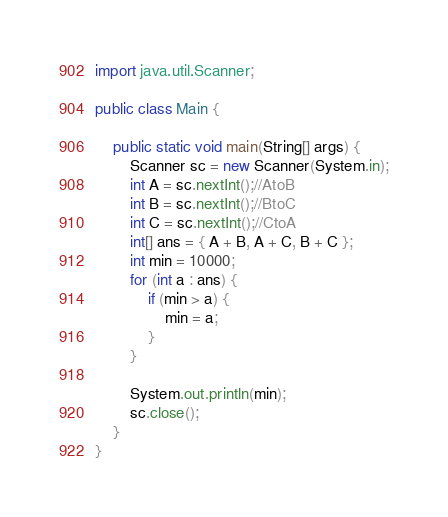<code> <loc_0><loc_0><loc_500><loc_500><_Java_>import java.util.Scanner;

public class Main {

	public static void main(String[] args) {
		Scanner sc = new Scanner(System.in);
		int A = sc.nextInt();//AtoB
		int B = sc.nextInt();//BtoC
		int C = sc.nextInt();//CtoA
		int[] ans = { A + B, A + C, B + C };
		int min = 10000;
		for (int a : ans) {
			if (min > a) {
				min = a;
			}
		}

		System.out.println(min);
		sc.close();
	}
}
</code> 